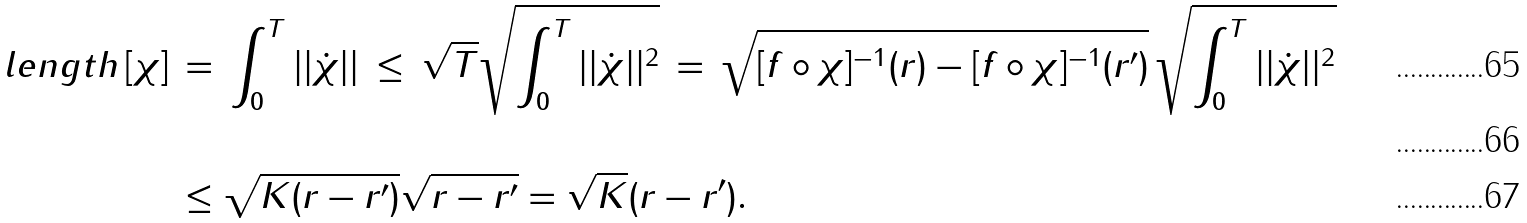Convert formula to latex. <formula><loc_0><loc_0><loc_500><loc_500>l e n g t h \, [ \chi ] \, & = \, \int _ { 0 } ^ { T } | | \dot { \chi } | | \, \leq \, \sqrt { T } \sqrt { \int _ { 0 } ^ { T } | | \dot { \chi } | | ^ { 2 } } \, = \, \sqrt { [ f \circ \chi ] ^ { - 1 } ( r ) - [ f \circ \chi ] ^ { - 1 } ( r ^ { \prime } ) } \, \sqrt { \int _ { 0 } ^ { T } | | \dot { \chi } | | ^ { 2 } } \\ & \\ & \leq \sqrt { K ( r - r ^ { \prime } ) } \sqrt { r - r ^ { \prime } } = \sqrt { K } ( r - r ^ { \prime } ) .</formula> 